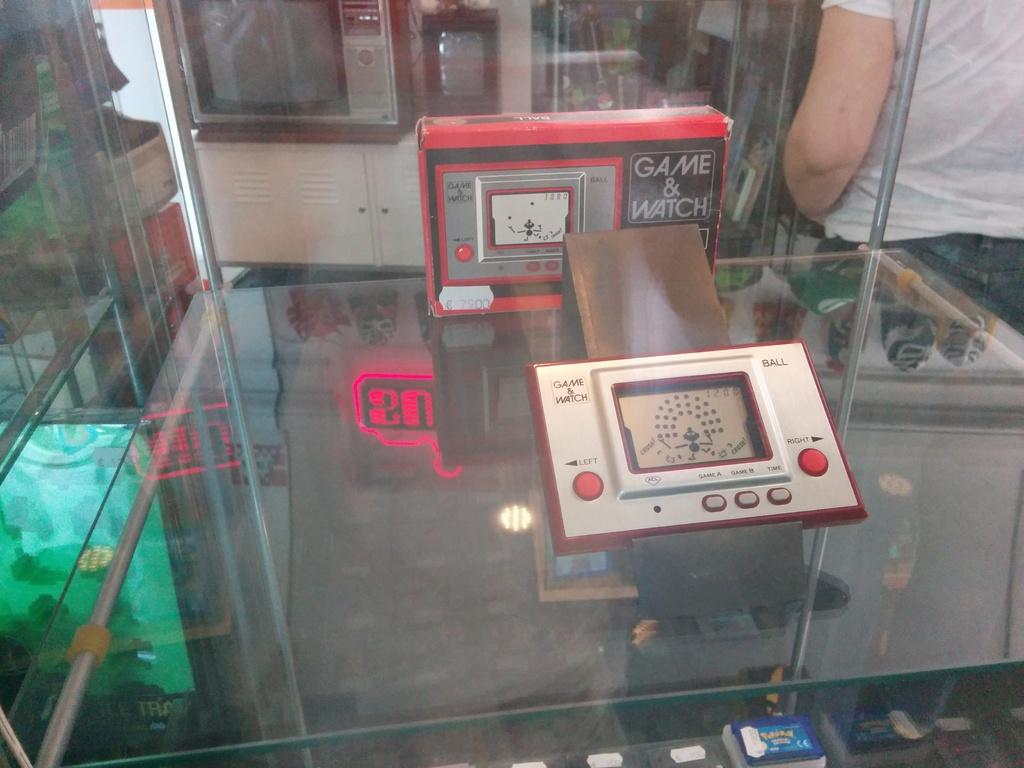What electronic device is the main focus of the image? There is a game watch in the image. Who or what is standing next to the game watch? There is a person standing next to the game watch. What other gaming items can be seen in the image? There are two game boxes on a glass surface in the image. What device might be used to display the game on a larger screen? There is a television in the image. What type of pest can be seen crawling on the game watch in the image? There are no pests visible in the image, and the game watch appears to be clean and undisturbed. 